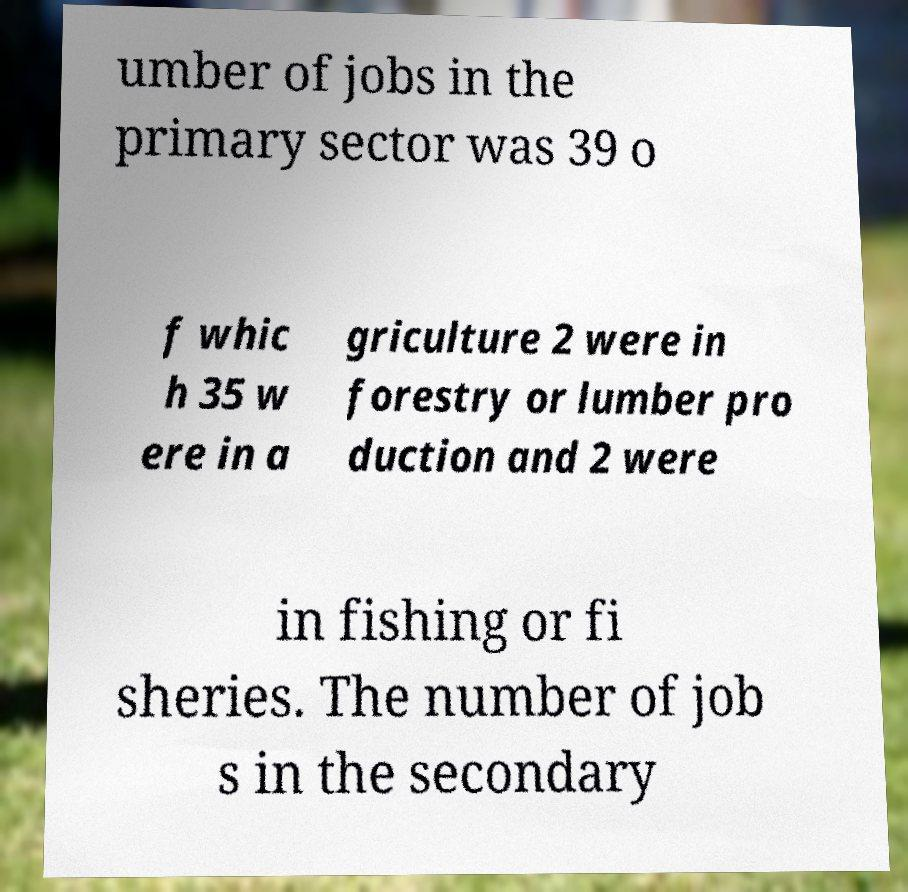Please identify and transcribe the text found in this image. umber of jobs in the primary sector was 39 o f whic h 35 w ere in a griculture 2 were in forestry or lumber pro duction and 2 were in fishing or fi sheries. The number of job s in the secondary 